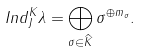<formula> <loc_0><loc_0><loc_500><loc_500>I n d _ { J } ^ { K } \lambda = \bigoplus _ { \sigma \in \widehat { K } } \sigma ^ { \oplus m _ { \sigma } } .</formula> 